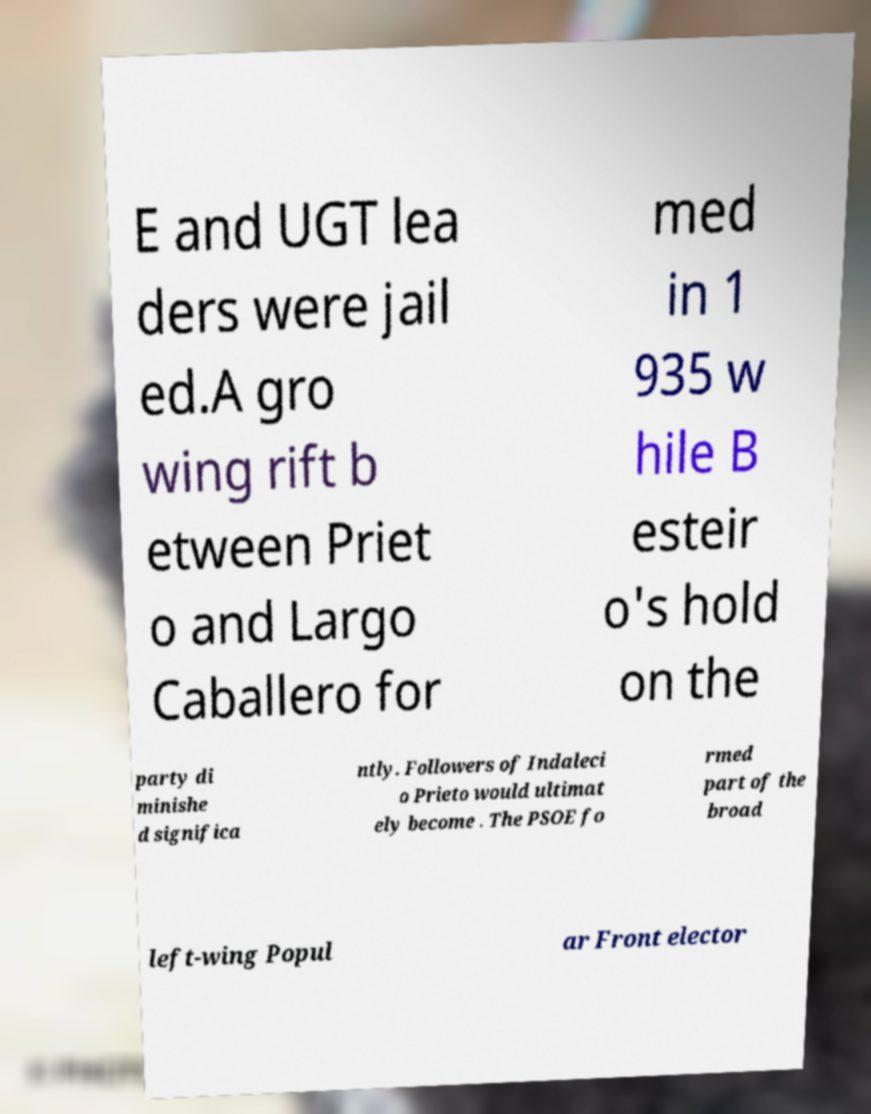I need the written content from this picture converted into text. Can you do that? E and UGT lea ders were jail ed.A gro wing rift b etween Priet o and Largo Caballero for med in 1 935 w hile B esteir o's hold on the party di minishe d significa ntly. Followers of Indaleci o Prieto would ultimat ely become . The PSOE fo rmed part of the broad left-wing Popul ar Front elector 